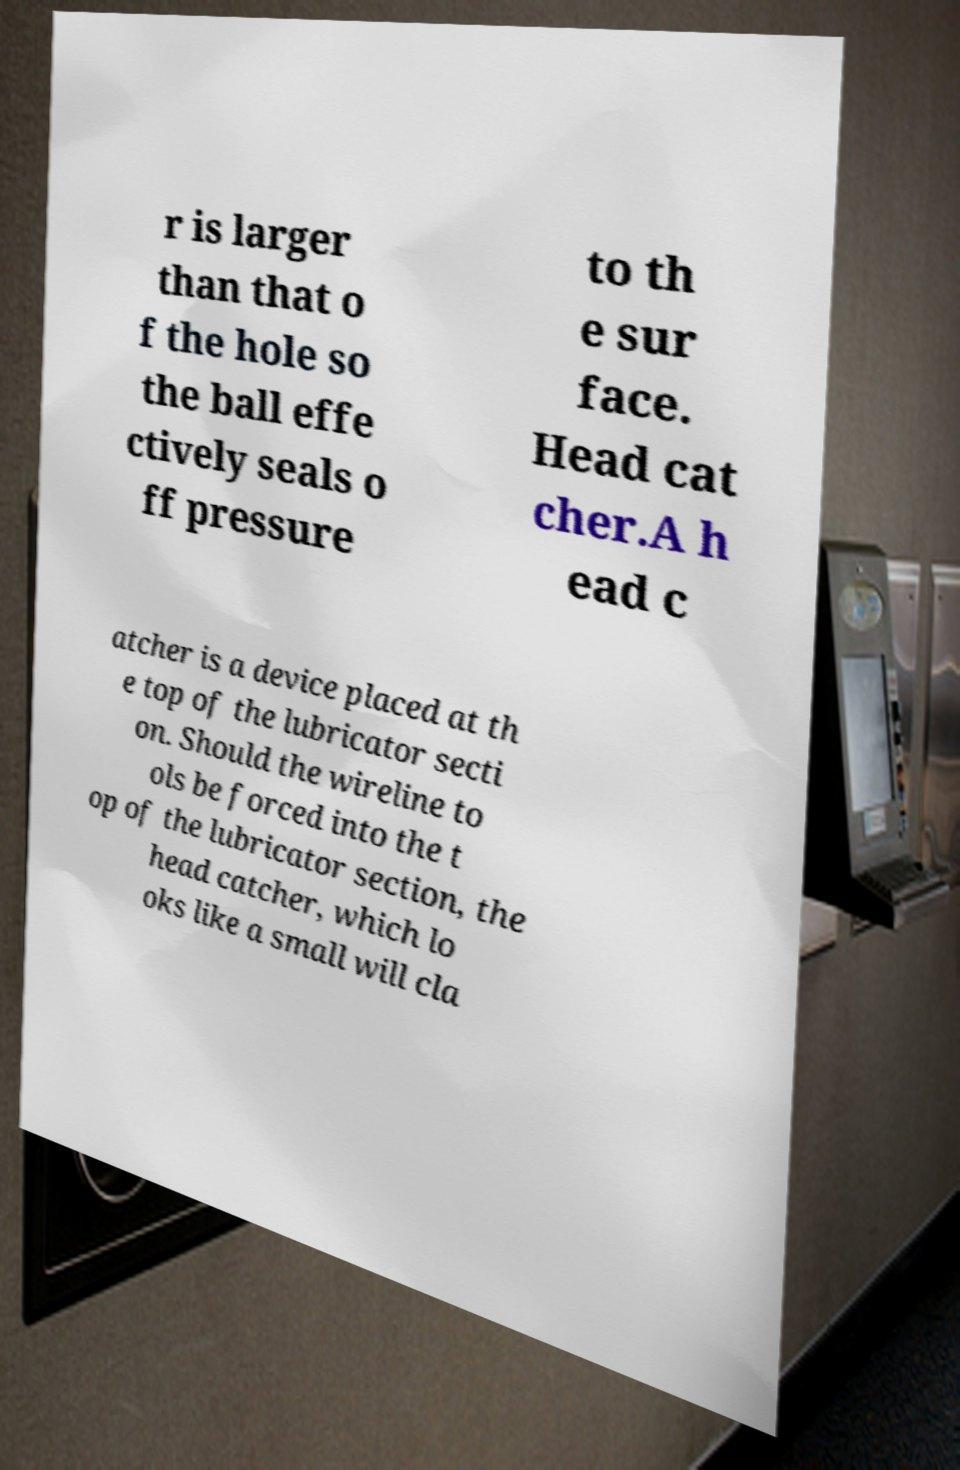Can you read and provide the text displayed in the image?This photo seems to have some interesting text. Can you extract and type it out for me? r is larger than that o f the hole so the ball effe ctively seals o ff pressure to th e sur face. Head cat cher.A h ead c atcher is a device placed at th e top of the lubricator secti on. Should the wireline to ols be forced into the t op of the lubricator section, the head catcher, which lo oks like a small will cla 